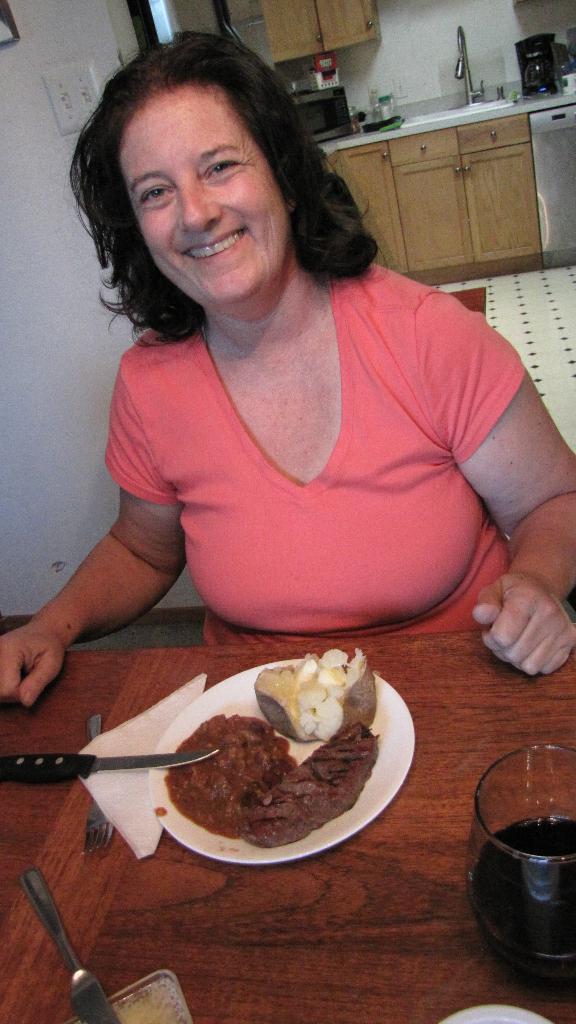In one or two sentences, can you explain what this image depicts? In this image we can see a lady. In front of her there is a wooden surface. On that there is a plate with food item, glass with drink, knife, fork and tissue. In the background there is a wall. Also we can see a platform with tap, microwave oven and some other items. 